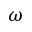Convert formula to latex. <formula><loc_0><loc_0><loc_500><loc_500>\omega</formula> 